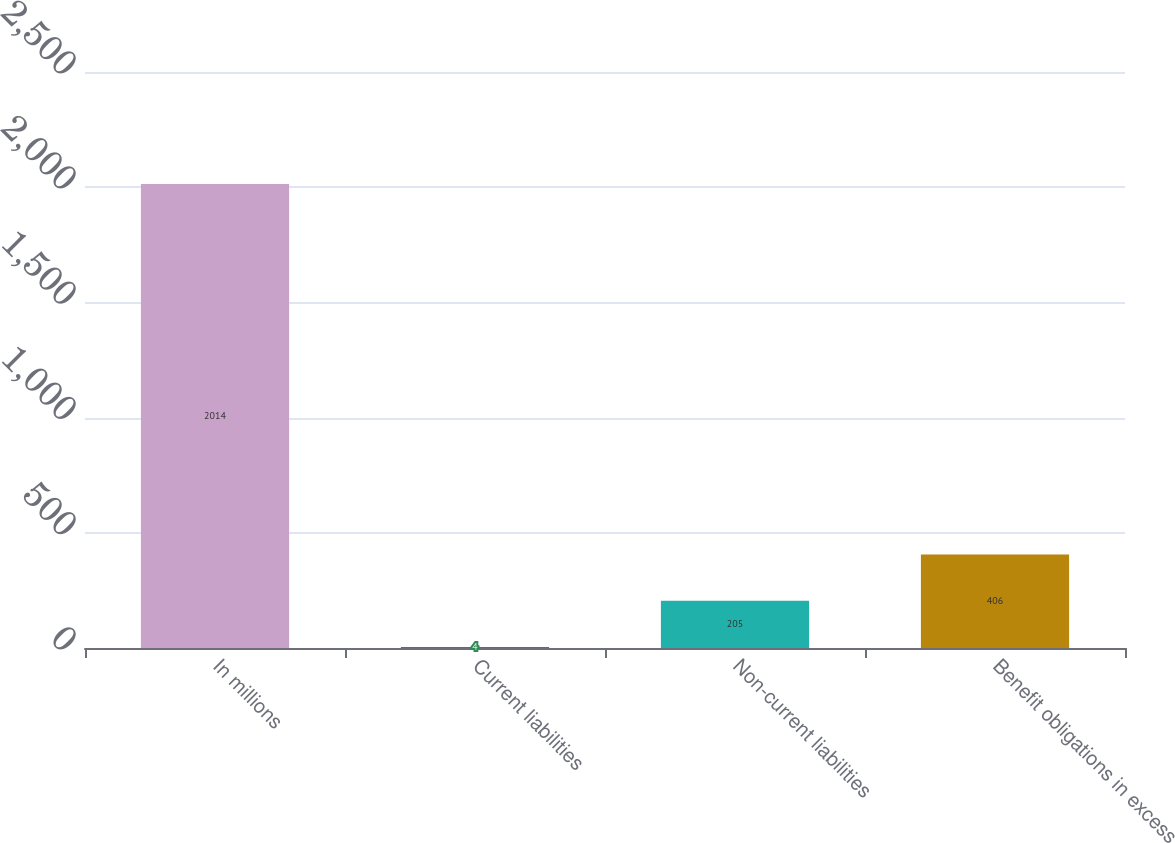Convert chart to OTSL. <chart><loc_0><loc_0><loc_500><loc_500><bar_chart><fcel>In millions<fcel>Current liabilities<fcel>Non-current liabilities<fcel>Benefit obligations in excess<nl><fcel>2014<fcel>4<fcel>205<fcel>406<nl></chart> 